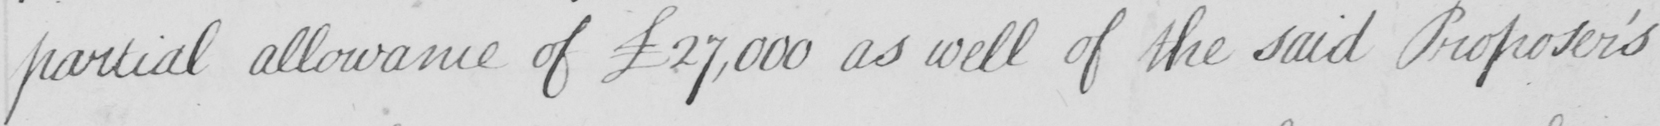Please transcribe the handwritten text in this image. partial allowance of  £27,000 as well of the said Proposer ' s 